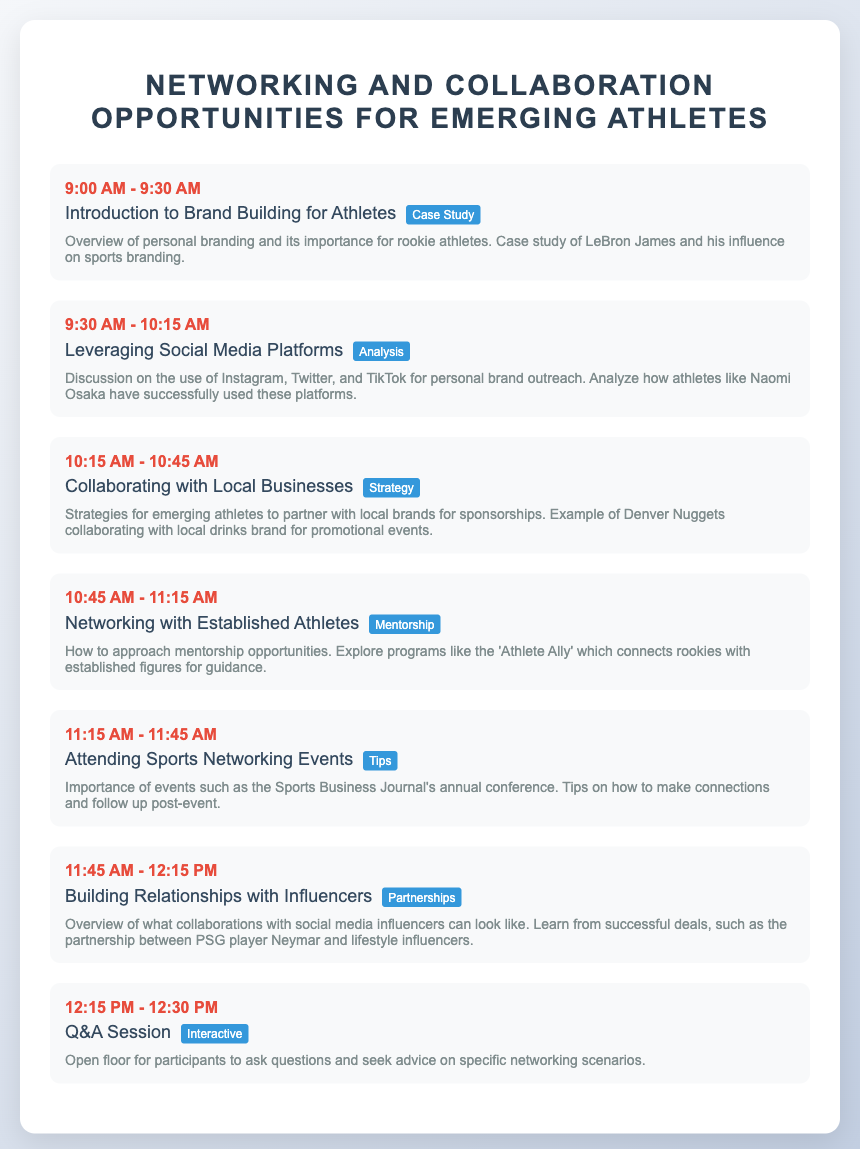What is the first agenda item? The first agenda item listed in the document is "Introduction to Brand Building for Athletes."
Answer: Introduction to Brand Building for Athletes What time does the session on "Collaborating with Local Businesses" start? The session begins at 10:15 AM.
Answer: 10:15 AM Who is the case study mentioned in the first item? The document mentions LeBron James as the case study for personal branding.
Answer: LeBron James What is one example of a successful athlete using social media? Naomi Osaka is noted for successfully using social media platforms.
Answer: Naomi Osaka What is the main focus of the Q&A Session? The Q&A Session allows participants to ask questions and seek advice on networking scenarios.
Answer: Open floor for questions Which session mentions attending sports networking events? The session titled "Attending Sports Networking Events" covers this topic.
Answer: Attending Sports Networking Events What type of collaboration is discussed in the session focusing on influencers? The session discusses building relationships with influencers for partnerships.
Answer: Partnerships What key opportunity does the "Networking with Established Athletes" session explore? Mentorship opportunities with established athletes are explored in this session.
Answer: Mentorship What is the highlighted topic of the last agenda item? The last agenda item is highlighted as "Interactive."
Answer: Interactive 